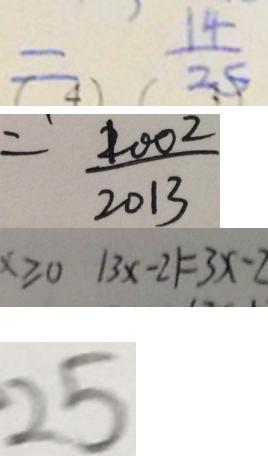<formula> <loc_0><loc_0><loc_500><loc_500>= \frac { 1 4 } { 2 5 } 
 = \frac { 1 0 0 2 } { 2 0 1 3 } 
 x \geqslant 0 \vert 3 x - 2 \vert = 3 x - 2 
 2 5</formula> 